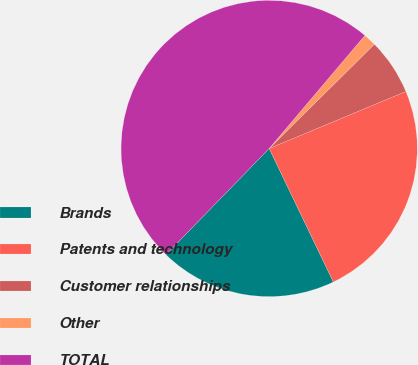Convert chart. <chart><loc_0><loc_0><loc_500><loc_500><pie_chart><fcel>Brands<fcel>Patents and technology<fcel>Customer relationships<fcel>Other<fcel>TOTAL<nl><fcel>19.41%<fcel>24.16%<fcel>6.14%<fcel>1.39%<fcel>48.9%<nl></chart> 